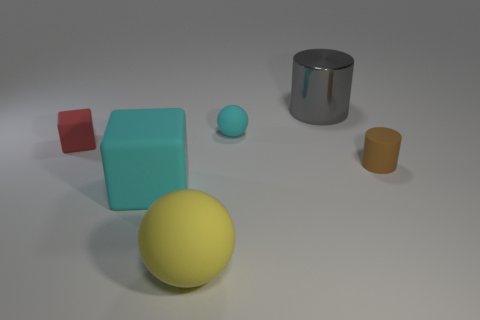Is there any indication of movement or interaction among the objects? The objects are positioned statically, with no clear indication of motion or interaction. The arrangement appears deliberate and poised for examination rather than suggesting a narrative of action or interaction. Each object casts its own shadow, signifying its individual placement without intersecting or overlapping with the others, further emphasizing their isolation. 